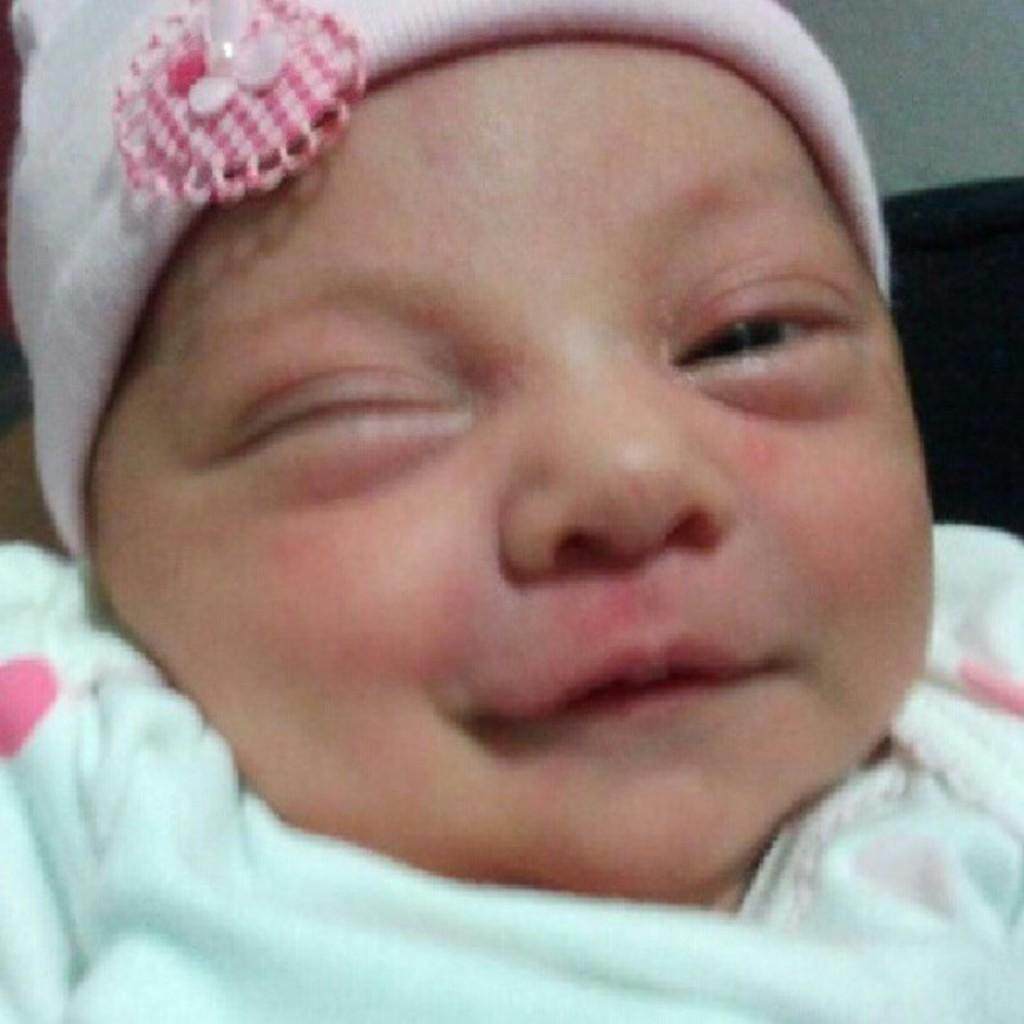Please provide a concise description of this image. In this image there is a baby with a monkey cap is smiling. 